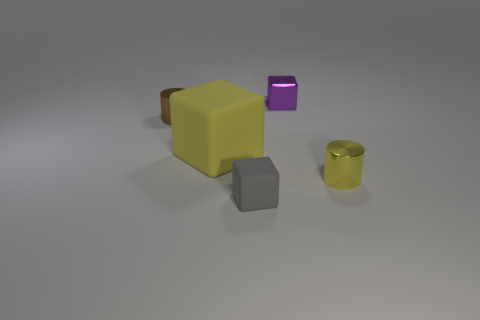Is there anything unique about the lighting or arrangement of the objects that stands out to you? The lighting appears to be soft and diffused, with gentle shadows cast by the three-dimensional objects, which enhances the tranquil atmosphere of the setting. The arrangement seems deliberate, as if showcasing the contrast in colors, shapes, and materials of the objects, possibly hinting at a minimalist artistic composition or a product display. 